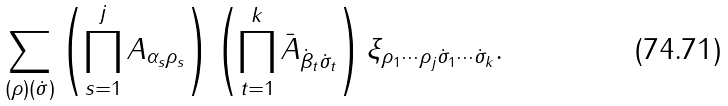Convert formula to latex. <formula><loc_0><loc_0><loc_500><loc_500>\sum _ { ( \rho ) ( \dot { \sigma } ) } \left ( \prod _ { s = 1 } ^ { j } A _ { \alpha _ { s } \rho _ { s } } \right ) \left ( \prod _ { t = 1 } ^ { k } \bar { A } _ { \dot { \beta } _ { t } \dot { \sigma } _ { t } } \right ) \xi _ { \rho _ { 1 } \cdots \rho _ { j } \dot { \sigma } _ { 1 } \cdots \dot { \sigma } _ { k } } .</formula> 